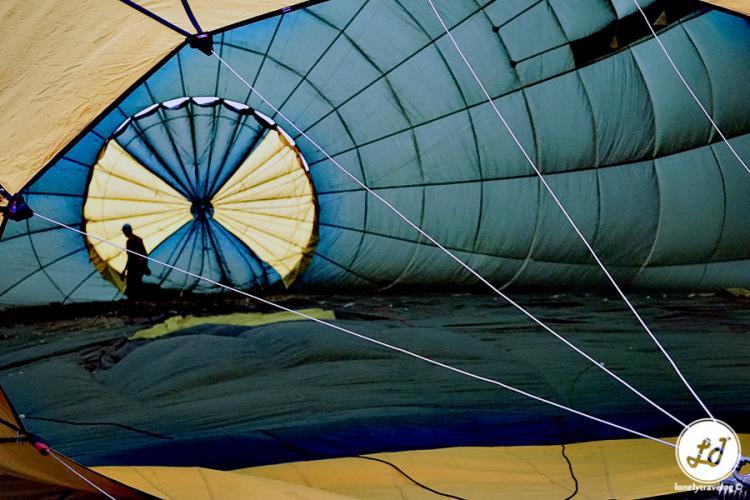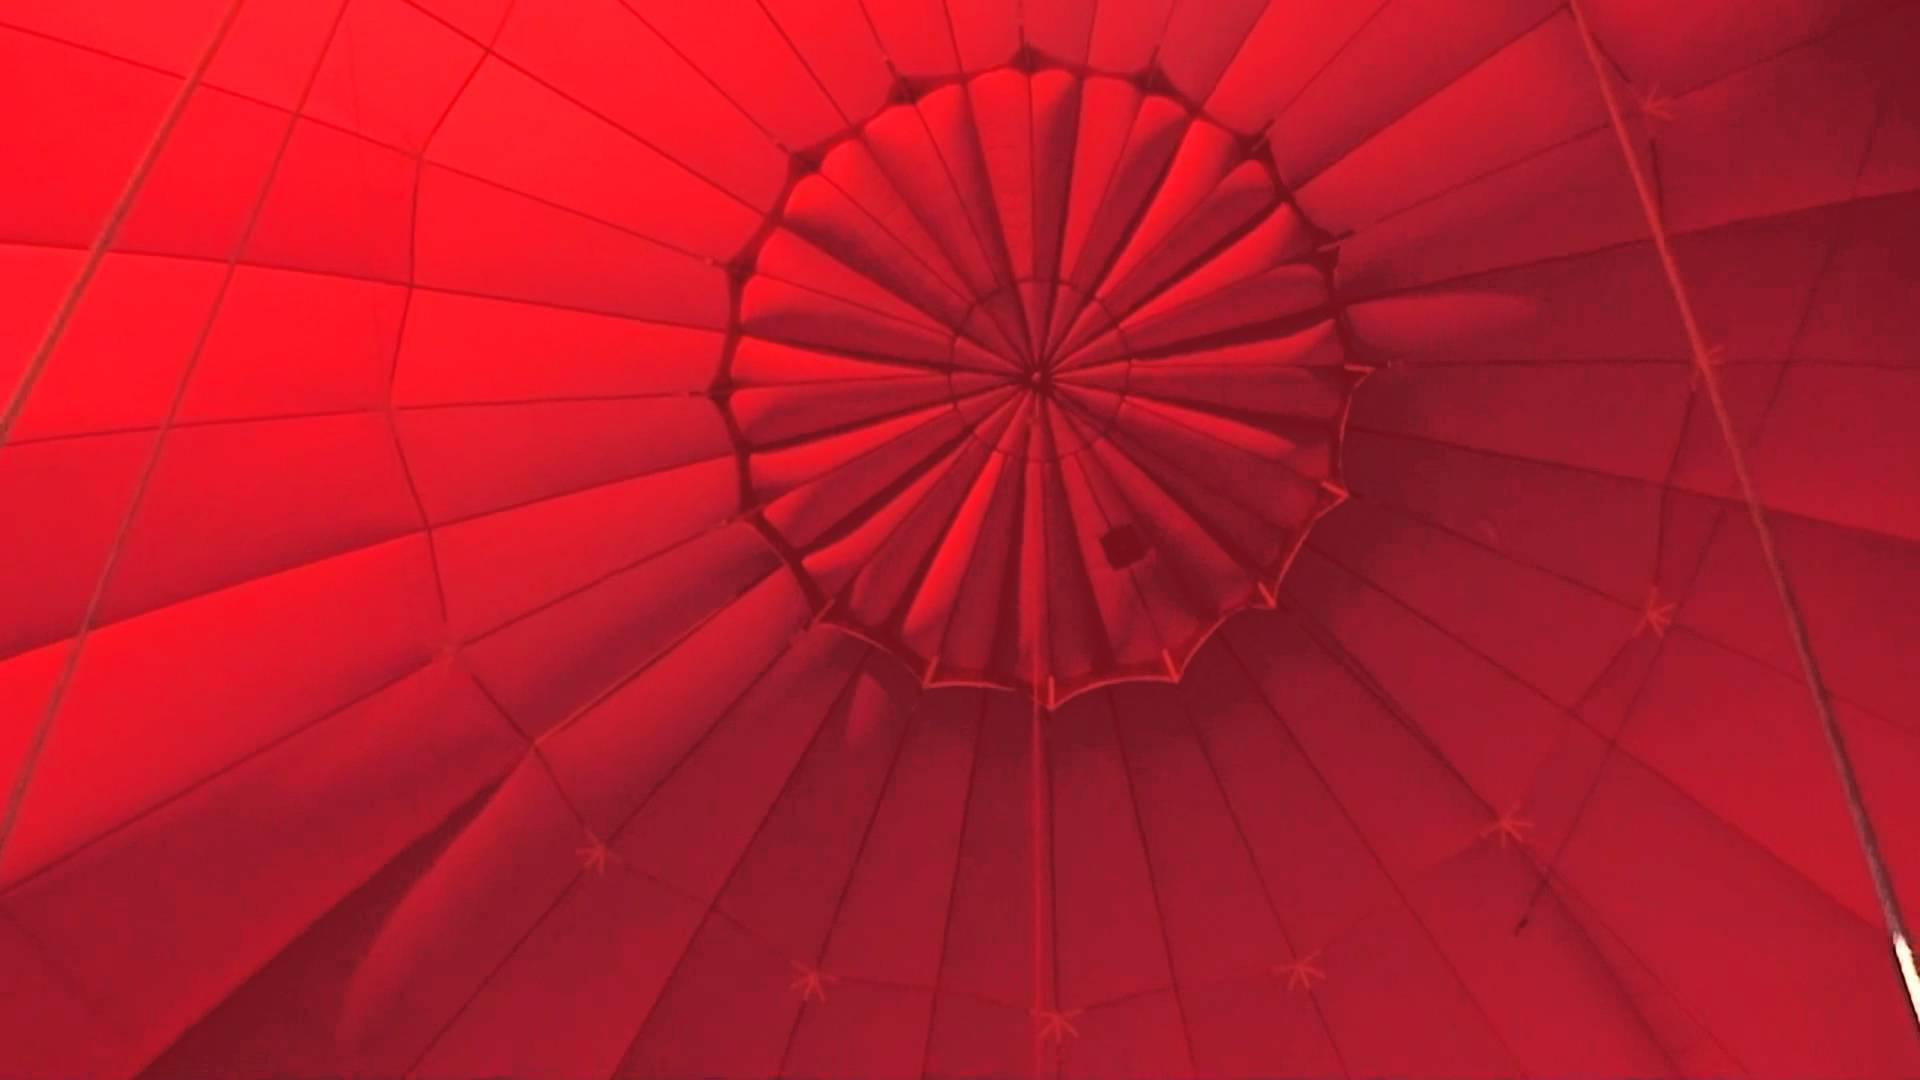The first image is the image on the left, the second image is the image on the right. For the images shown, is this caption "There is a person in one of the images" true? Answer yes or no. Yes. The first image is the image on the left, the second image is the image on the right. Assess this claim about the two images: "The parachute in the right image contains at least four colors.". Correct or not? Answer yes or no. No. 